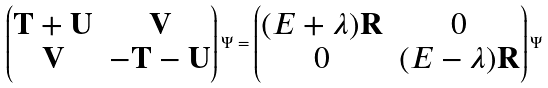<formula> <loc_0><loc_0><loc_500><loc_500>\left ( \begin{matrix} \mathbf T + \mathbf U & \mathbf V \\ \mathbf V & - \mathbf T - \mathbf U \end{matrix} \right ) \Psi = \left ( \begin{matrix} ( E + \lambda ) \mathbf R & 0 \\ 0 & ( E - \lambda ) \mathbf R \end{matrix} \right ) \Psi</formula> 